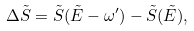<formula> <loc_0><loc_0><loc_500><loc_500>\Delta \tilde { S } = \tilde { S } ( \tilde { E } - \omega ^ { \prime } ) - \tilde { S } ( \tilde { E } ) ,</formula> 